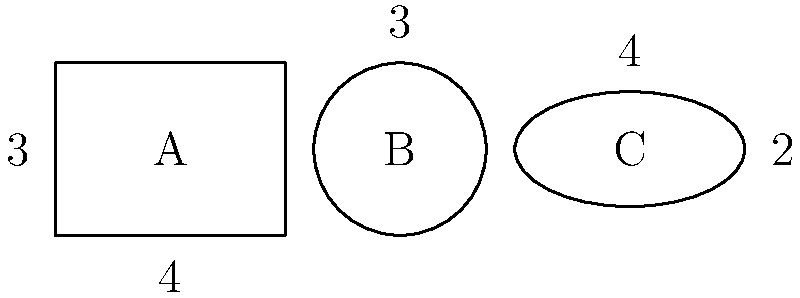As a produce stocker, you need to maximize shelf space efficiency. You have three container shapes for storing organic fruits: a rectangular box (A), a circular container (B), and an elliptical container (C). The dimensions are shown in the diagram (in feet). If you need to store 100 cubic feet of produce, which container shape would be the most space-efficient choice in terms of floor space occupied? To determine the most space-efficient container, we need to calculate the volume and floor space for each shape:

1. Rectangular box (A):
   Volume: $V_A = 4 \times 3 \times 4 = 48$ cubic feet
   Floor space: $S_A = 4 \times 4 = 16$ square feet

2. Circular container (B):
   Volume: $V_B = \pi r^2 h = \pi \times 1.5^2 \times 3 = 21.21$ cubic feet
   Floor space: $S_B = \pi r^2 = \pi \times 1.5^2 = 7.07$ square feet

3. Elliptical container (C):
   Volume: $V_C = \pi a b h = \pi \times 2 \times 1 \times 4 = 25.13$ cubic feet
   Floor space: $S_C = \pi a b = \pi \times 2 \times 1 = 6.28$ square feet

Now, let's calculate how many of each container we need to store 100 cubic feet:

A: $100 \div 48 = 2.08$ containers (round up to 3)
B: $100 \div 21.21 = 4.71$ containers (round up to 5)
C: $100 \div 25.13 = 3.98$ containers (round up to 4)

Total floor space needed:
A: $3 \times 16 = 48$ square feet
B: $5 \times 7.07 = 35.35$ square feet
C: $4 \times 6.28 = 25.12$ square feet

The elliptical container (C) requires the least floor space to store 100 cubic feet of produce, making it the most space-efficient choice.
Answer: Elliptical container (C) 